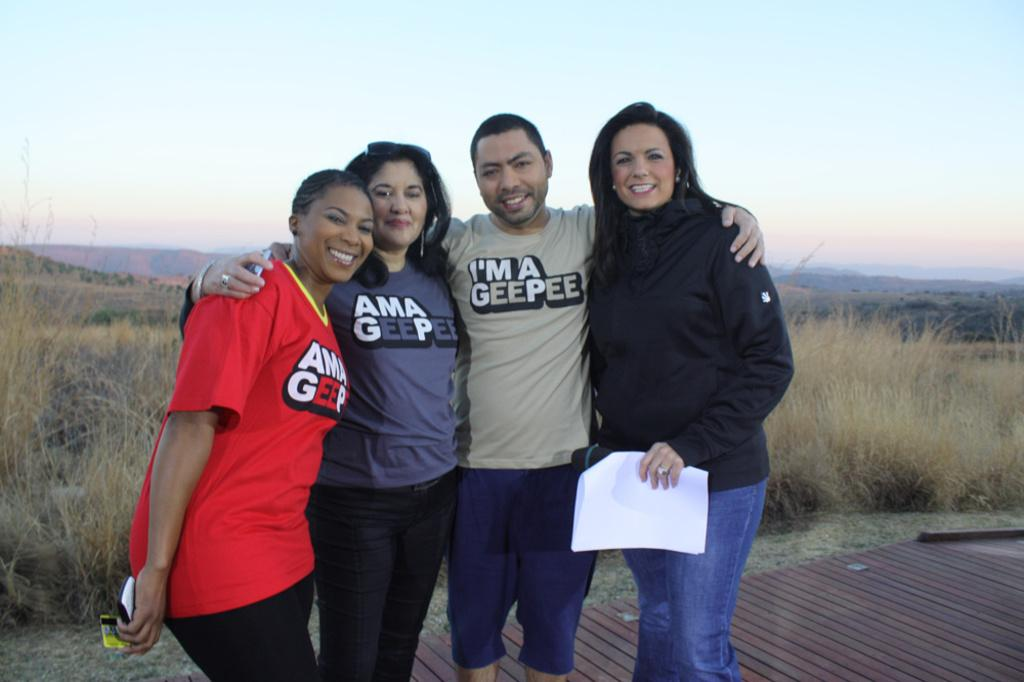How many people are in the image? There are three women and a man in the image. What is one of the women doing in the image? One of the women is holding a paper in her hands and smiling. What can be seen in the background of the image? There is grass, hills, and the sky visible in the background of the image. What type of bean is growing on the hair of the man in the image? There is no bean or hair visible on the man in the image. 